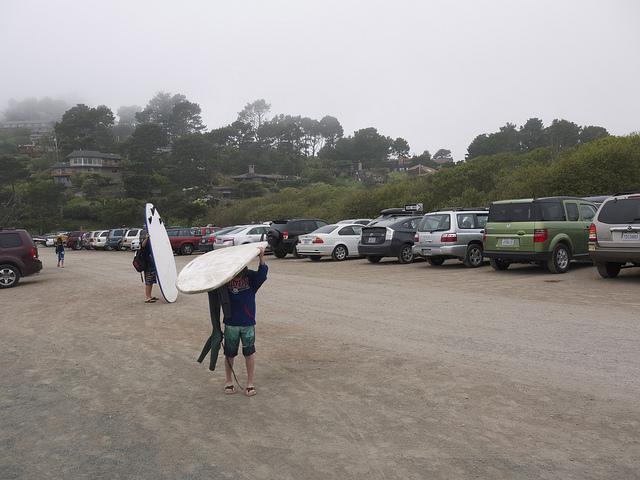How many cars are visible?
Give a very brief answer. 4. 